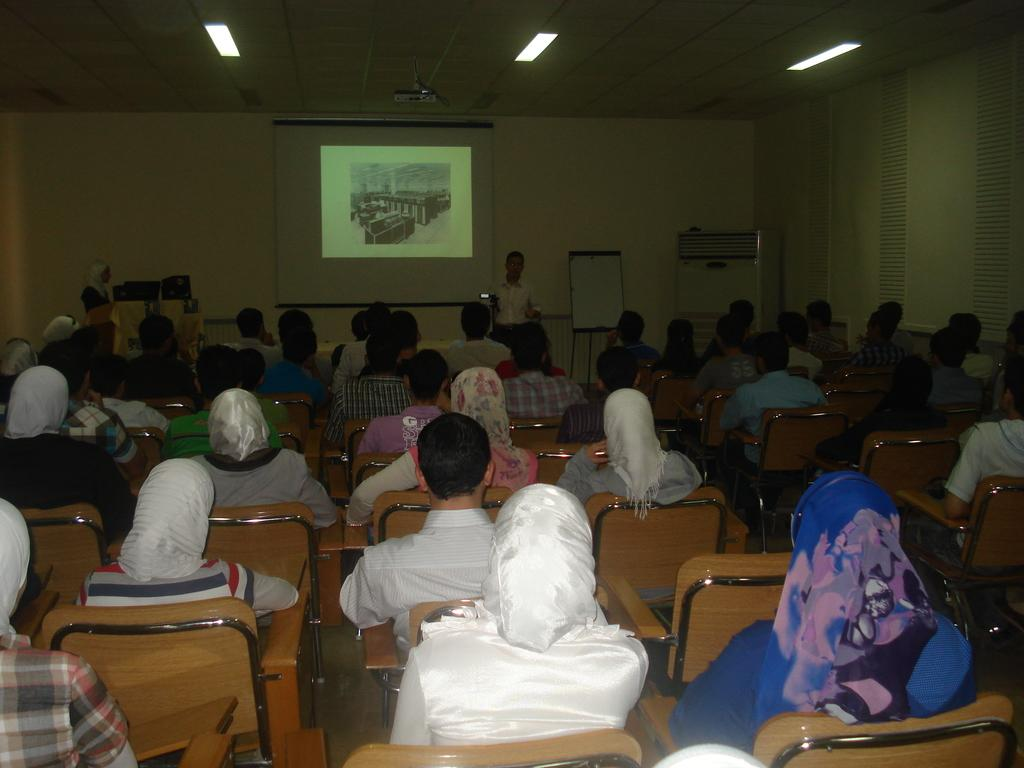How many people are in the image? There is a group of people in the image, but the exact number is not specified. What are the people doing in the image? The people are sitting in the image. What objects are in front of the people? There are tables in front of the people. What can be seen on the wall or screen in the image? There is a projector screen in the image. What type of dress is the giraffe wearing in the image? There is no giraffe present in the image, and therefore no dress or any other clothing item can be attributed to it. 